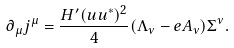<formula> <loc_0><loc_0><loc_500><loc_500>\partial _ { \mu } j ^ { \mu } = \frac { H ^ { \prime } ( u u ^ { * } ) ^ { 2 } } { 4 } ( \Lambda _ { \nu } - e A _ { \nu } ) \Sigma ^ { \nu } .</formula> 